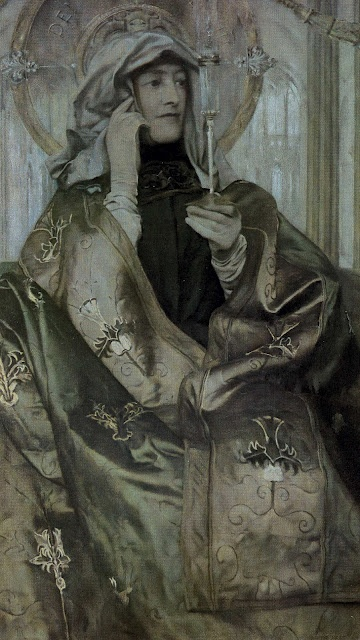Imagine if this woman lived in a fantastical world, what might her role be? In a fantastical world, this woman could be imagined as a wise and revered sorceress or a mystical queen. Her elegant attire and serene demeanor suggest a person of great wisdom and spiritual depth. Perhaps she is a guardian of ancient knowledge or a healer with the power to cure ailments using rare and enchanted flora, like the white flower she delicately holds. Her presence brings a sense of peace and reverence, making her an essential figure in maintaining the balance and harmony of her fantastical realm. 